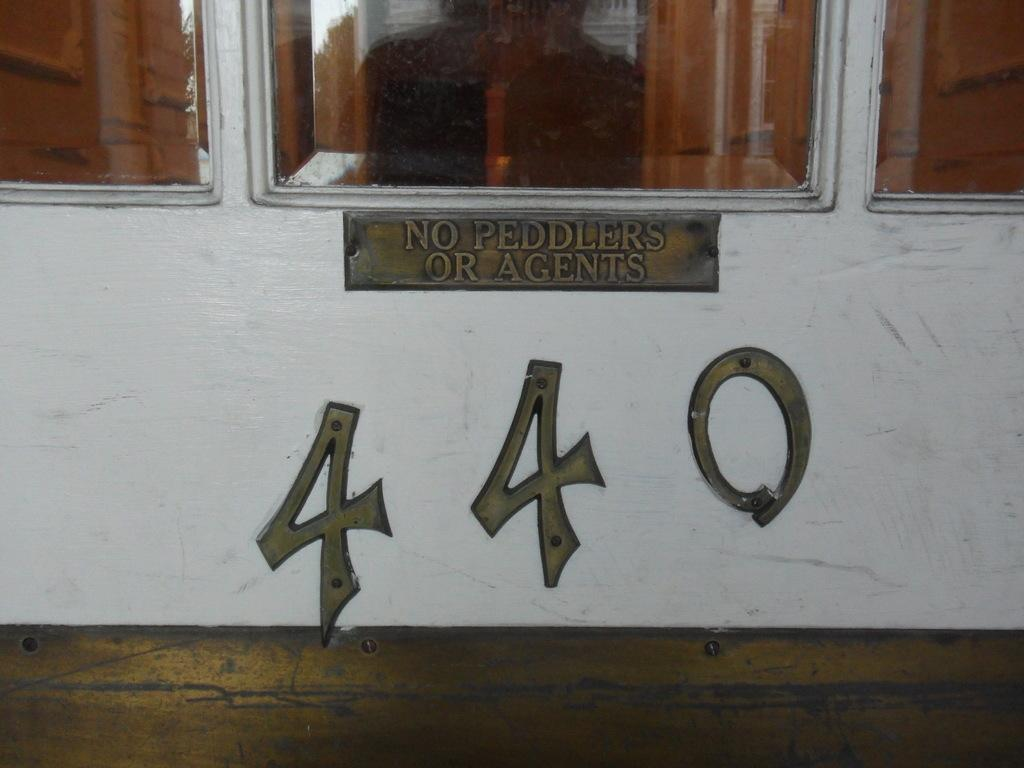What type of vehicle is in the picture? There is a bus in the picture. What colors are used for the bus? The bus is white and golden in color. Is there any text visible on the bus? Yes, "four forty" is written on the bus. What can be seen above the bus in the image? There are glass windows visible above the bus. What type of beef is being served on the bus in the image? There is no beef present in the image; it features a bus with specific colors and text. 